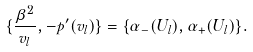<formula> <loc_0><loc_0><loc_500><loc_500>\{ \frac { \beta ^ { 2 } } { v _ { l } } , - p ^ { \prime } ( v _ { l } ) \} = \{ \alpha _ { - } ( U _ { l } ) , \alpha _ { + } ( U _ { l } ) \} .</formula> 